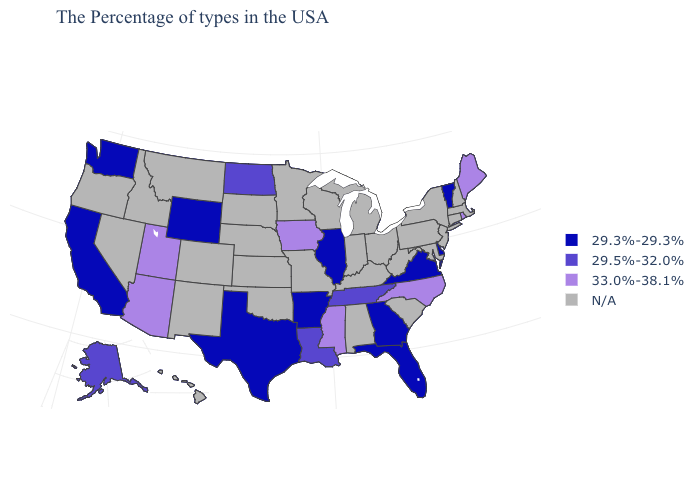Among the states that border New Jersey , which have the highest value?
Write a very short answer. Delaware. What is the value of Vermont?
Quick response, please. 29.3%-29.3%. What is the highest value in the Northeast ?
Give a very brief answer. 33.0%-38.1%. What is the lowest value in the USA?
Answer briefly. 29.3%-29.3%. What is the highest value in the West ?
Be succinct. 33.0%-38.1%. Name the states that have a value in the range 29.5%-32.0%?
Be succinct. Tennessee, Louisiana, North Dakota, Alaska. What is the value of Montana?
Give a very brief answer. N/A. What is the value of Alaska?
Keep it brief. 29.5%-32.0%. Does Tennessee have the lowest value in the South?
Answer briefly. No. What is the value of Wyoming?
Quick response, please. 29.3%-29.3%. Name the states that have a value in the range 33.0%-38.1%?
Give a very brief answer. Maine, Rhode Island, North Carolina, Mississippi, Iowa, Utah, Arizona. Name the states that have a value in the range 29.3%-29.3%?
Write a very short answer. Vermont, Delaware, Virginia, Florida, Georgia, Illinois, Arkansas, Texas, Wyoming, California, Washington. What is the value of Wyoming?
Concise answer only. 29.3%-29.3%. 